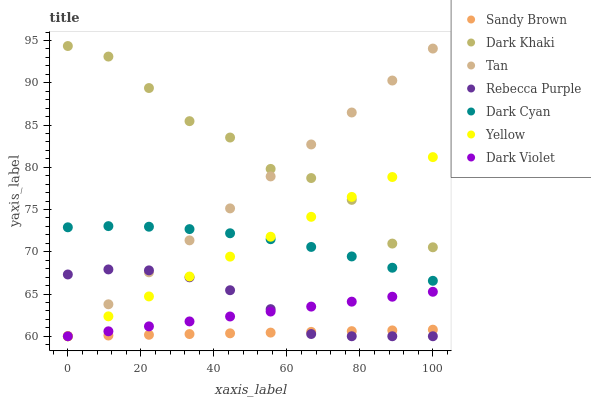Does Sandy Brown have the minimum area under the curve?
Answer yes or no. Yes. Does Dark Khaki have the maximum area under the curve?
Answer yes or no. Yes. Does Yellow have the minimum area under the curve?
Answer yes or no. No. Does Yellow have the maximum area under the curve?
Answer yes or no. No. Is Sandy Brown the smoothest?
Answer yes or no. Yes. Is Dark Khaki the roughest?
Answer yes or no. Yes. Is Yellow the smoothest?
Answer yes or no. No. Is Yellow the roughest?
Answer yes or no. No. Does Dark Violet have the lowest value?
Answer yes or no. Yes. Does Dark Khaki have the lowest value?
Answer yes or no. No. Does Dark Khaki have the highest value?
Answer yes or no. Yes. Does Yellow have the highest value?
Answer yes or no. No. Is Dark Violet less than Dark Cyan?
Answer yes or no. Yes. Is Dark Cyan greater than Dark Violet?
Answer yes or no. Yes. Does Tan intersect Dark Cyan?
Answer yes or no. Yes. Is Tan less than Dark Cyan?
Answer yes or no. No. Is Tan greater than Dark Cyan?
Answer yes or no. No. Does Dark Violet intersect Dark Cyan?
Answer yes or no. No. 